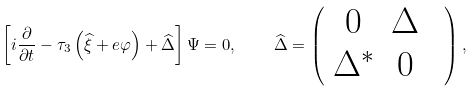<formula> <loc_0><loc_0><loc_500><loc_500>\left [ i \frac { \partial } { \partial t } - \tau _ { 3 } \left ( \widehat { \xi } + e \varphi \right ) + \widehat { \Delta } \right ] { \Psi } = 0 , \quad \widehat { \Delta } = \left ( \begin{array} { c c c } 0 & \Delta & \\ \Delta ^ { \ast } & 0 & \end{array} \right ) ,</formula> 